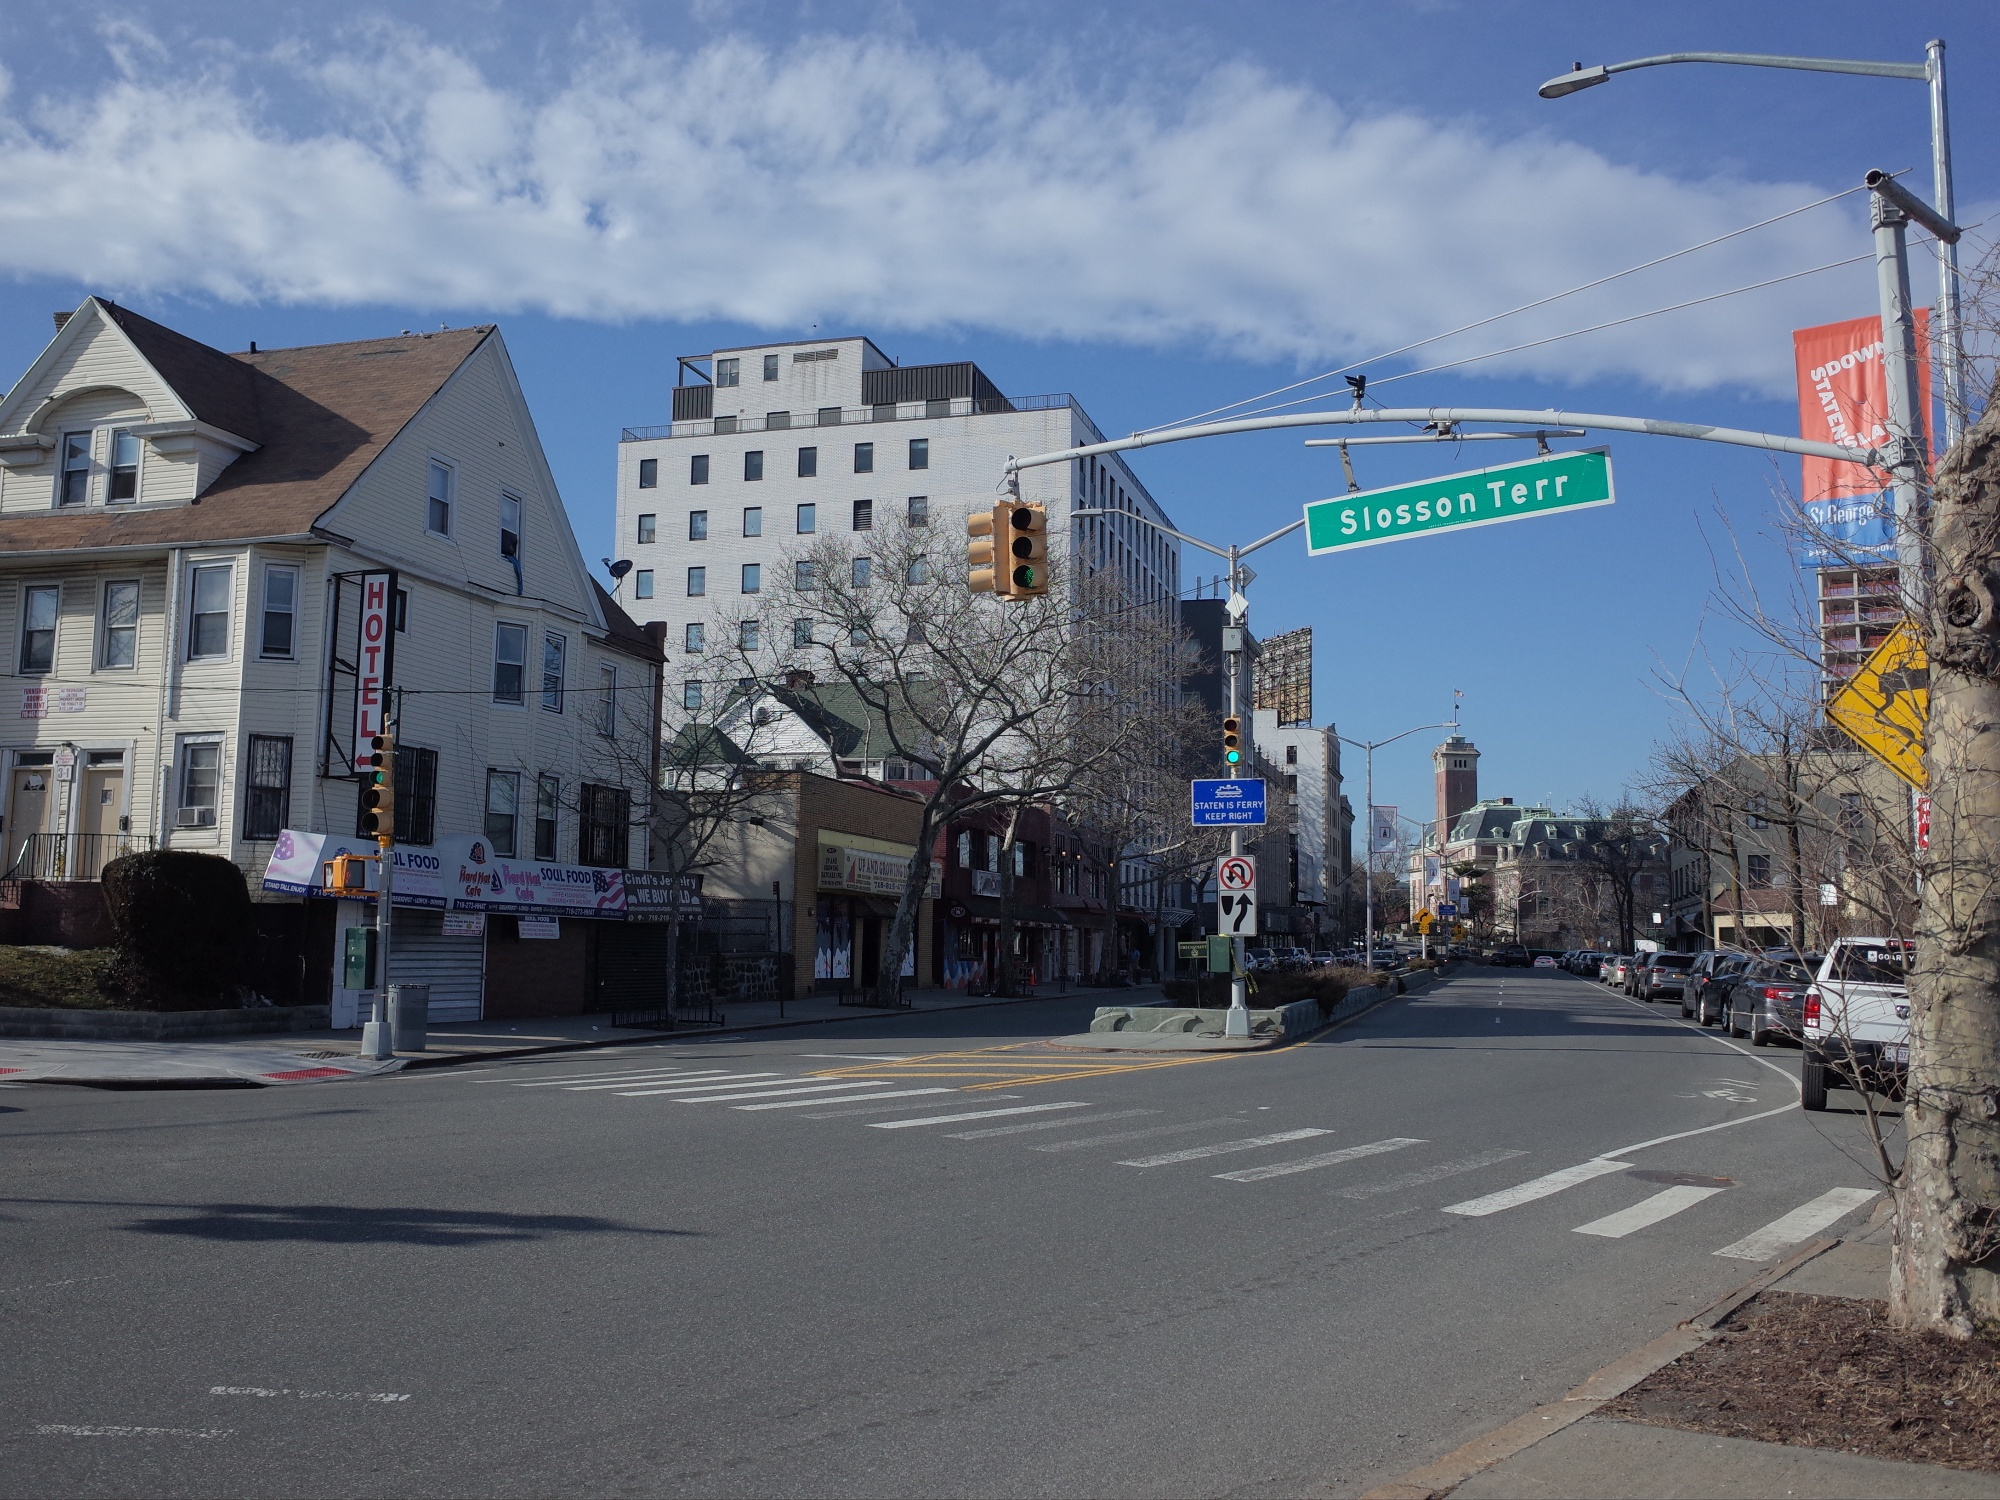Invent a story that involves an event happening at this location. One crisp autumn morning, the tranquility of Slosson Terrace was broken by the buzz of excitement. The annual city marathon had chosen this intersection as a key checkpoint. Volunteers set up water stations in front of the hotel, and vibrant banners fluttered from the street signs. Spectators started to gather, their anticipation palpable as they cheered on the runners. Among them was a local hero, a young woman running in memory of her grandfather, who used to own a small shop just down the street. The image now recorded not just a serene city moment but a vibrant celebration of community and endurance. Describe a peaceful scenario happening in this scene. As the sun began to set, an elderly couple strolled hand in hand down Slosson Terrace. The quiet street with its tall trees and historical buildings provided a perfect backdrop for their evening walk. They paused occasionally to admire the resilient beauty of the facade of the buildings or to share a memory tied to the area. The calmness of the scene offered them a moment of peace and reflection, a gentle reminder of the simple joys of life amidst the quiet hum of the city. 